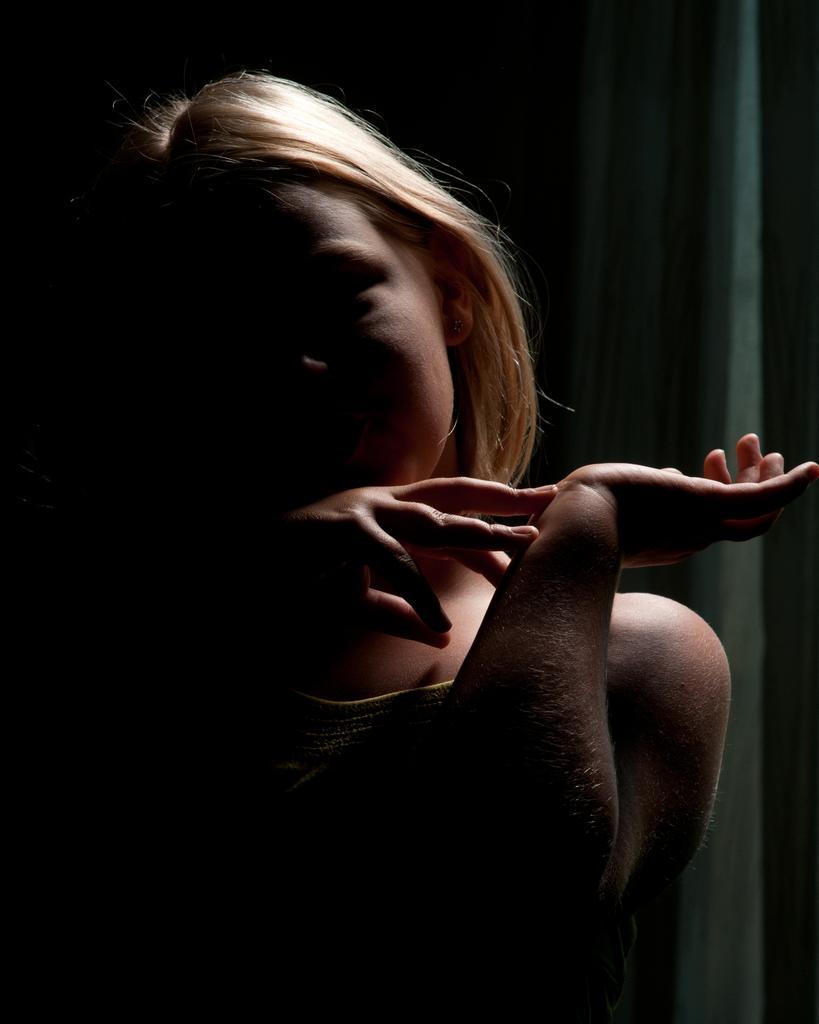Can you describe this image briefly? Background portion of the picture is dark and blur. In this picture we can see a person. 